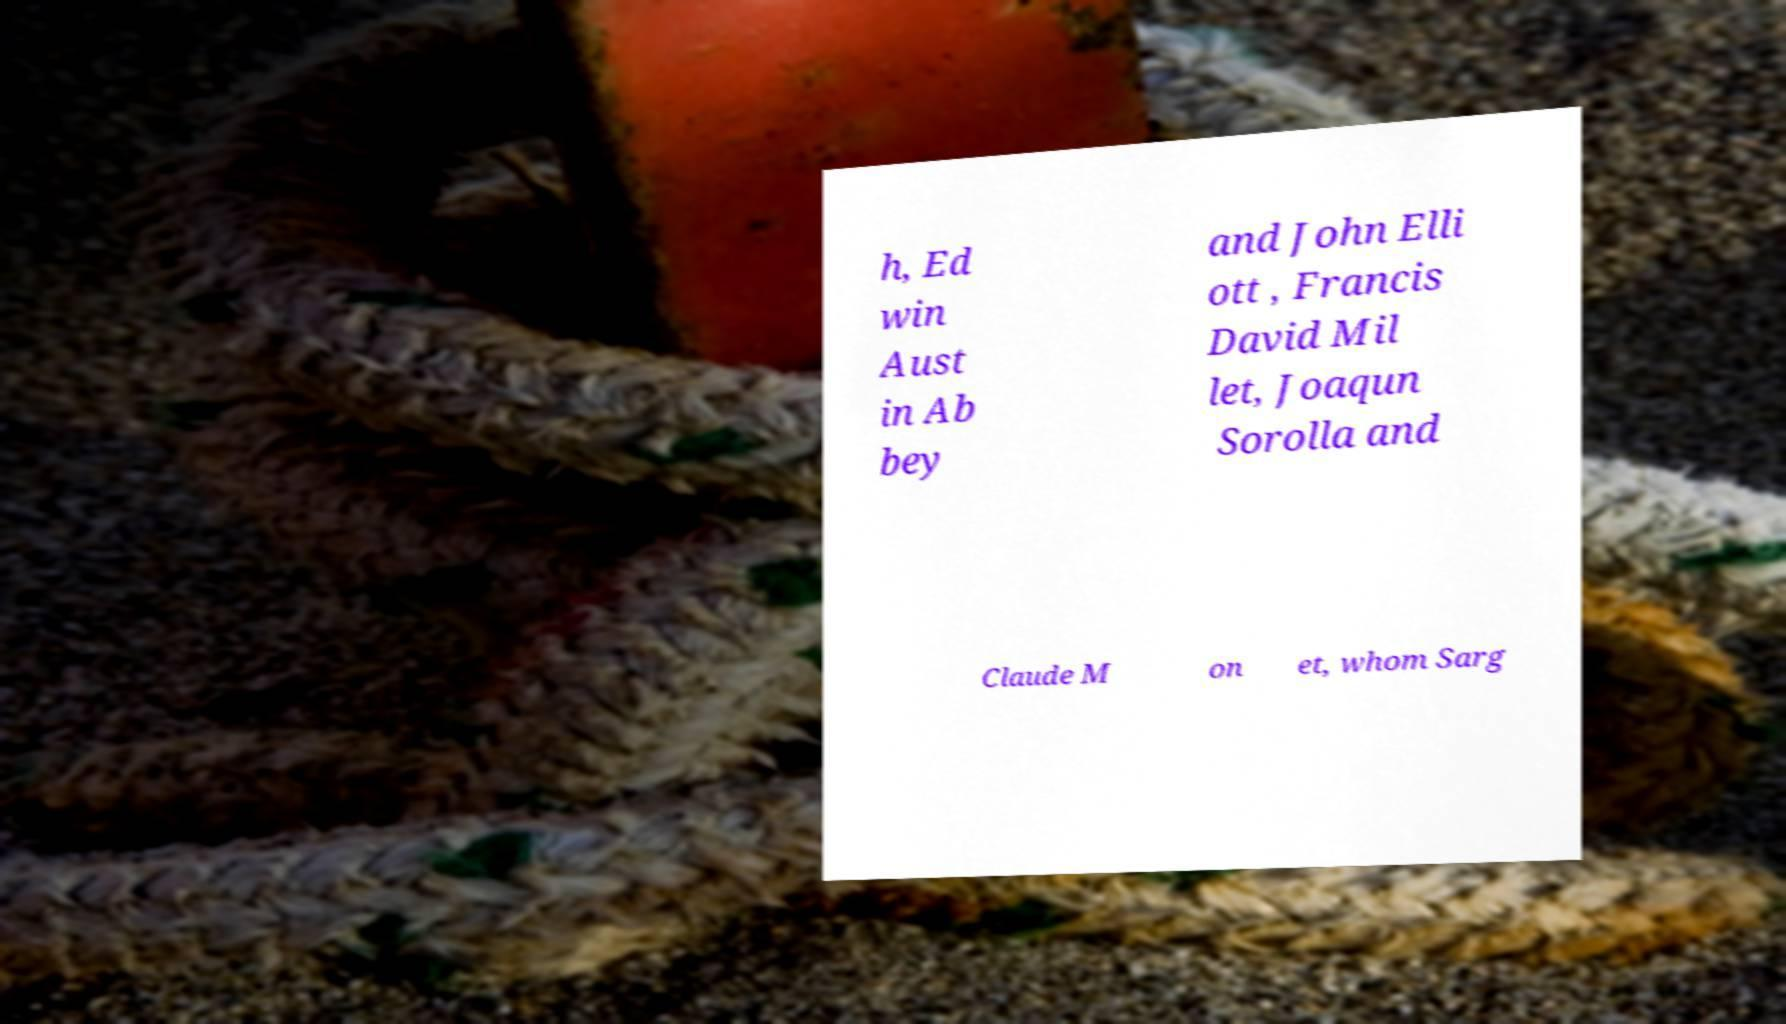For documentation purposes, I need the text within this image transcribed. Could you provide that? h, Ed win Aust in Ab bey and John Elli ott , Francis David Mil let, Joaqun Sorolla and Claude M on et, whom Sarg 